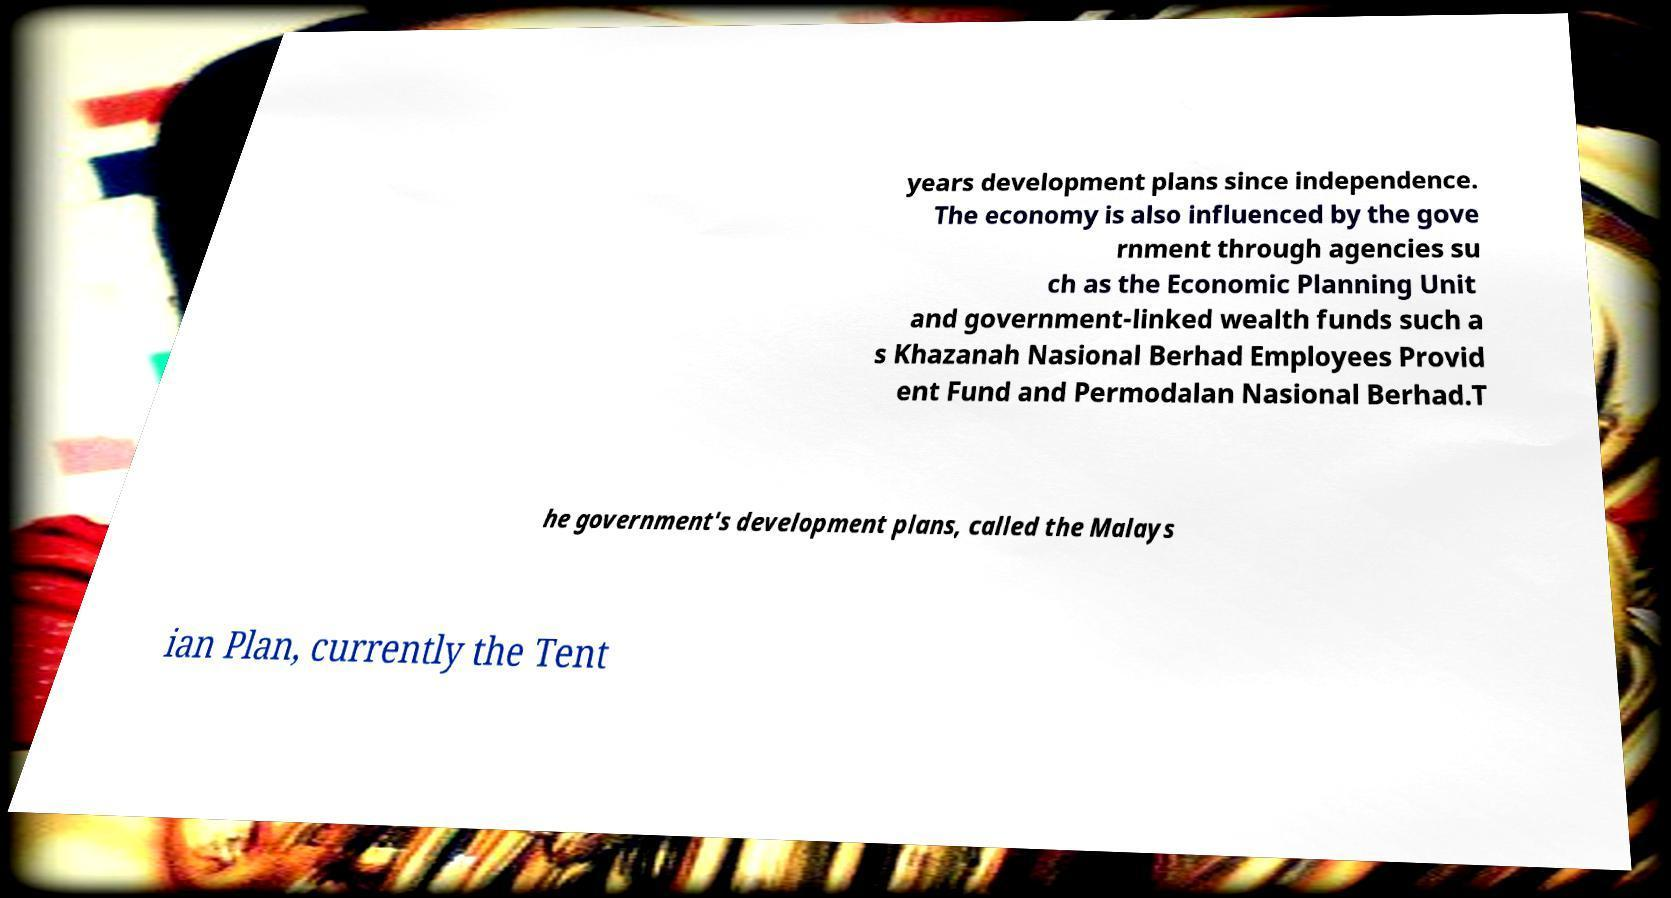I need the written content from this picture converted into text. Can you do that? years development plans since independence. The economy is also influenced by the gove rnment through agencies su ch as the Economic Planning Unit and government-linked wealth funds such a s Khazanah Nasional Berhad Employees Provid ent Fund and Permodalan Nasional Berhad.T he government's development plans, called the Malays ian Plan, currently the Tent 